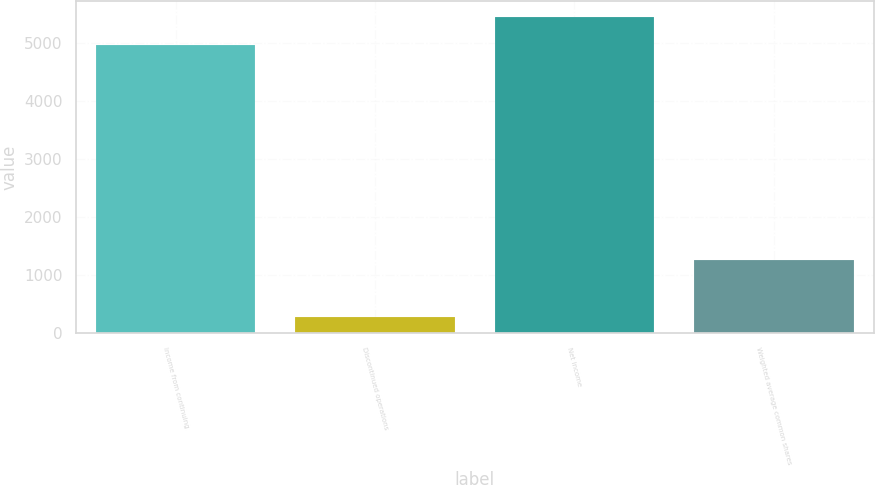<chart> <loc_0><loc_0><loc_500><loc_500><bar_chart><fcel>Income from continuing<fcel>Discontinued operations<fcel>Net income<fcel>Weighted average common shares<nl><fcel>4957<fcel>277<fcel>5452.7<fcel>1268.4<nl></chart> 